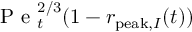Convert formula to latex. <formula><loc_0><loc_0><loc_500><loc_500>P e _ { t } ^ { 2 / 3 } ( 1 - r _ { p e a k , I } ( t ) )</formula> 